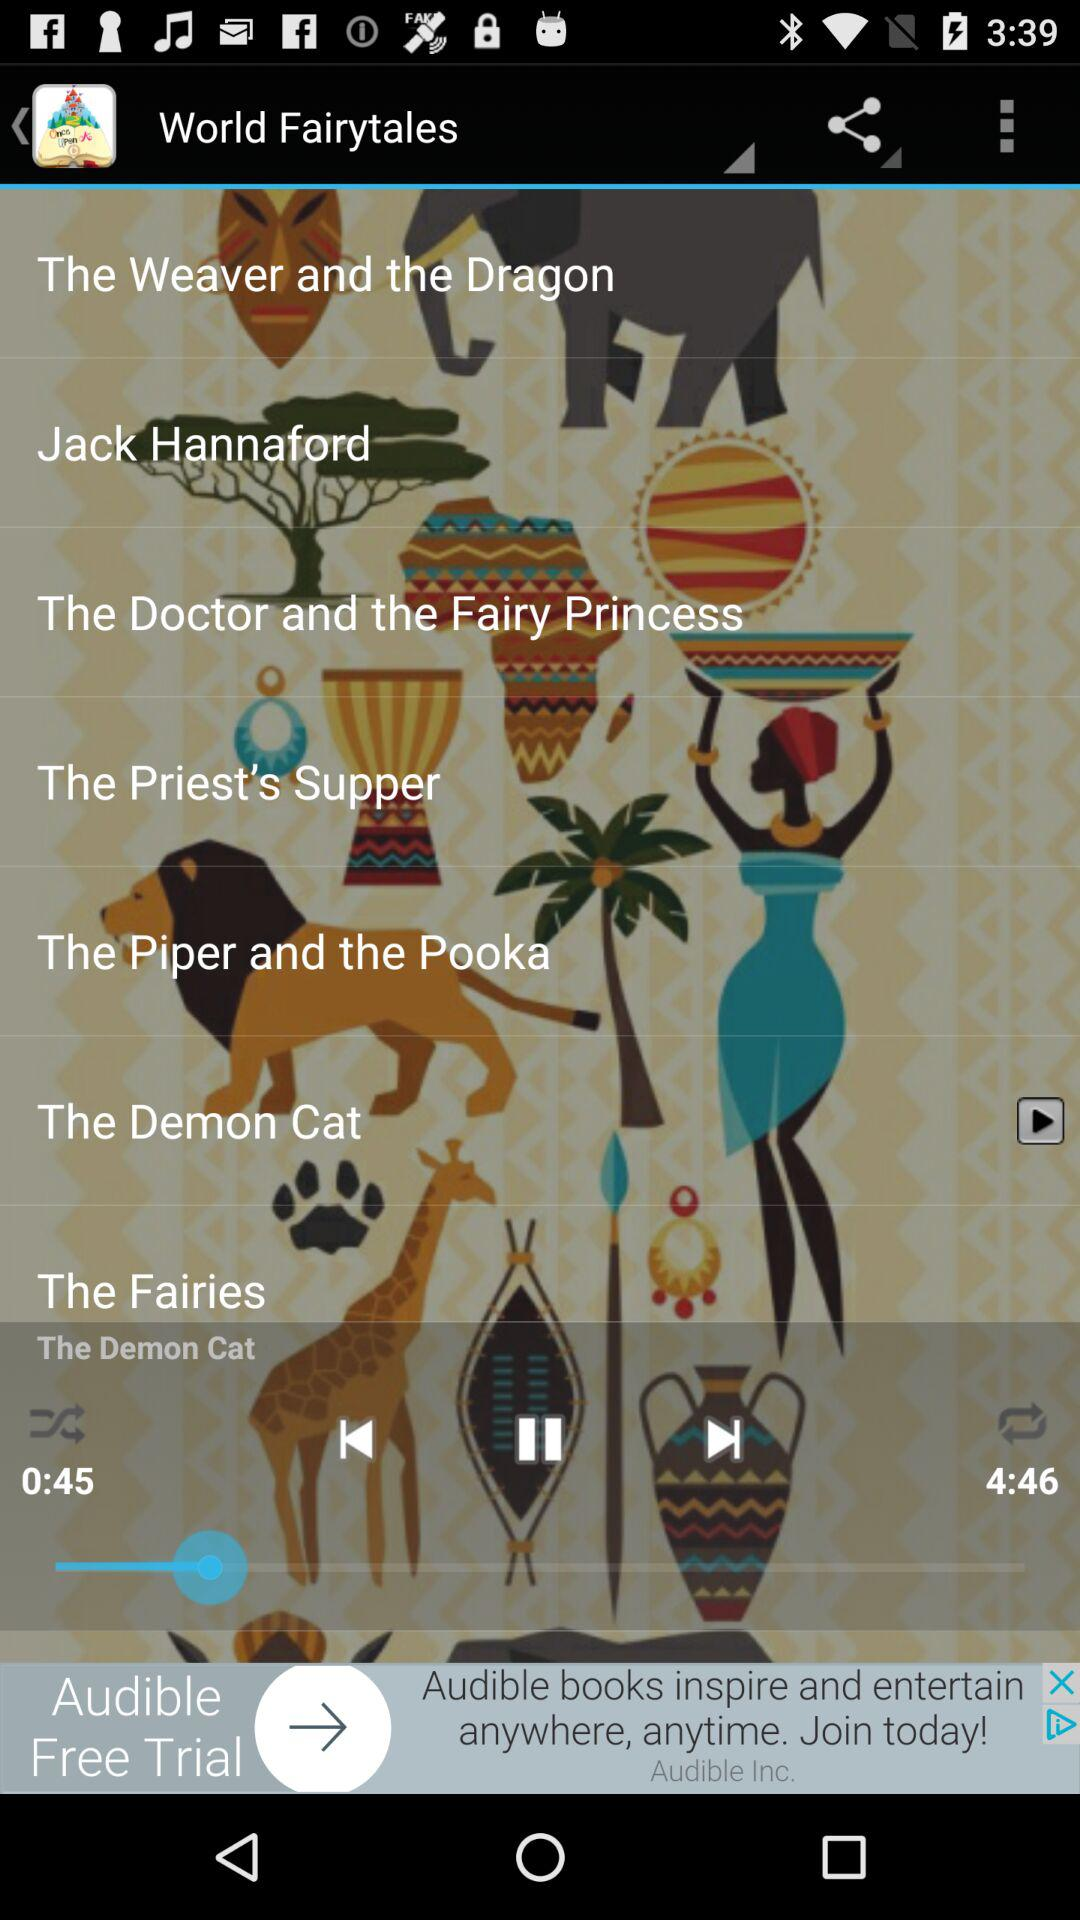What is the duration of "The Demon Cat"? The duration of "The Demon Cat" is 4 minutes 46 seconds. 